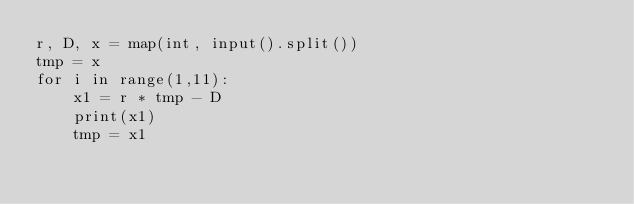Convert code to text. <code><loc_0><loc_0><loc_500><loc_500><_Python_>r, D, x = map(int, input().split())
tmp = x
for i in range(1,11):
    x1 = r * tmp - D
    print(x1)
    tmp = x1</code> 